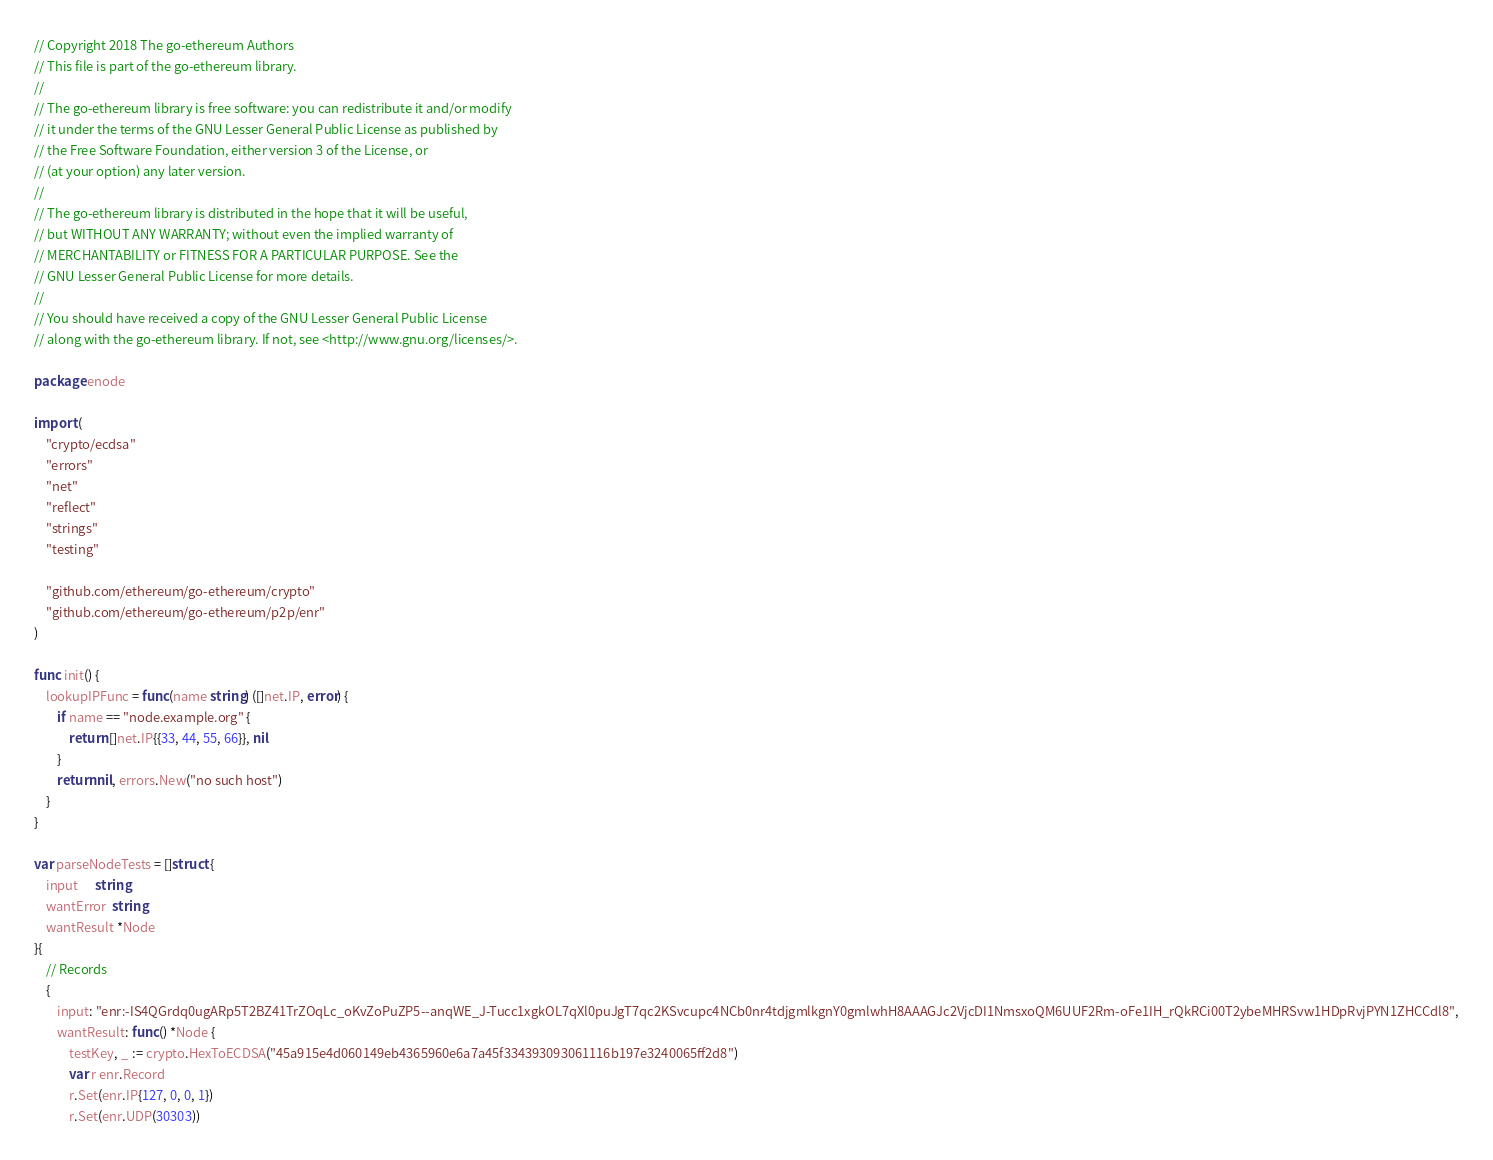Convert code to text. <code><loc_0><loc_0><loc_500><loc_500><_Go_>// Copyright 2018 The go-ethereum Authors
// This file is part of the go-ethereum library.
//
// The go-ethereum library is free software: you can redistribute it and/or modify
// it under the terms of the GNU Lesser General Public License as published by
// the Free Software Foundation, either version 3 of the License, or
// (at your option) any later version.
//
// The go-ethereum library is distributed in the hope that it will be useful,
// but WITHOUT ANY WARRANTY; without even the implied warranty of
// MERCHANTABILITY or FITNESS FOR A PARTICULAR PURPOSE. See the
// GNU Lesser General Public License for more details.
//
// You should have received a copy of the GNU Lesser General Public License
// along with the go-ethereum library. If not, see <http://www.gnu.org/licenses/>.

package enode

import (
	"crypto/ecdsa"
	"errors"
	"net"
	"reflect"
	"strings"
	"testing"

	"github.com/ethereum/go-ethereum/crypto"
	"github.com/ethereum/go-ethereum/p2p/enr"
)

func init() {
	lookupIPFunc = func(name string) ([]net.IP, error) {
		if name == "node.example.org" {
			return []net.IP{{33, 44, 55, 66}}, nil
		}
		return nil, errors.New("no such host")
	}
}

var parseNodeTests = []struct {
	input      string
	wantError  string
	wantResult *Node
}{
	// Records
	{
		input: "enr:-IS4QGrdq0ugARp5T2BZ41TrZOqLc_oKvZoPuZP5--anqWE_J-Tucc1xgkOL7qXl0puJgT7qc2KSvcupc4NCb0nr4tdjgmlkgnY0gmlwhH8AAAGJc2VjcDI1NmsxoQM6UUF2Rm-oFe1IH_rQkRCi00T2ybeMHRSvw1HDpRvjPYN1ZHCCdl8",
		wantResult: func() *Node {
			testKey, _ := crypto.HexToECDSA("45a915e4d060149eb4365960e6a7a45f334393093061116b197e3240065ff2d8")
			var r enr.Record
			r.Set(enr.IP{127, 0, 0, 1})
			r.Set(enr.UDP(30303))</code> 